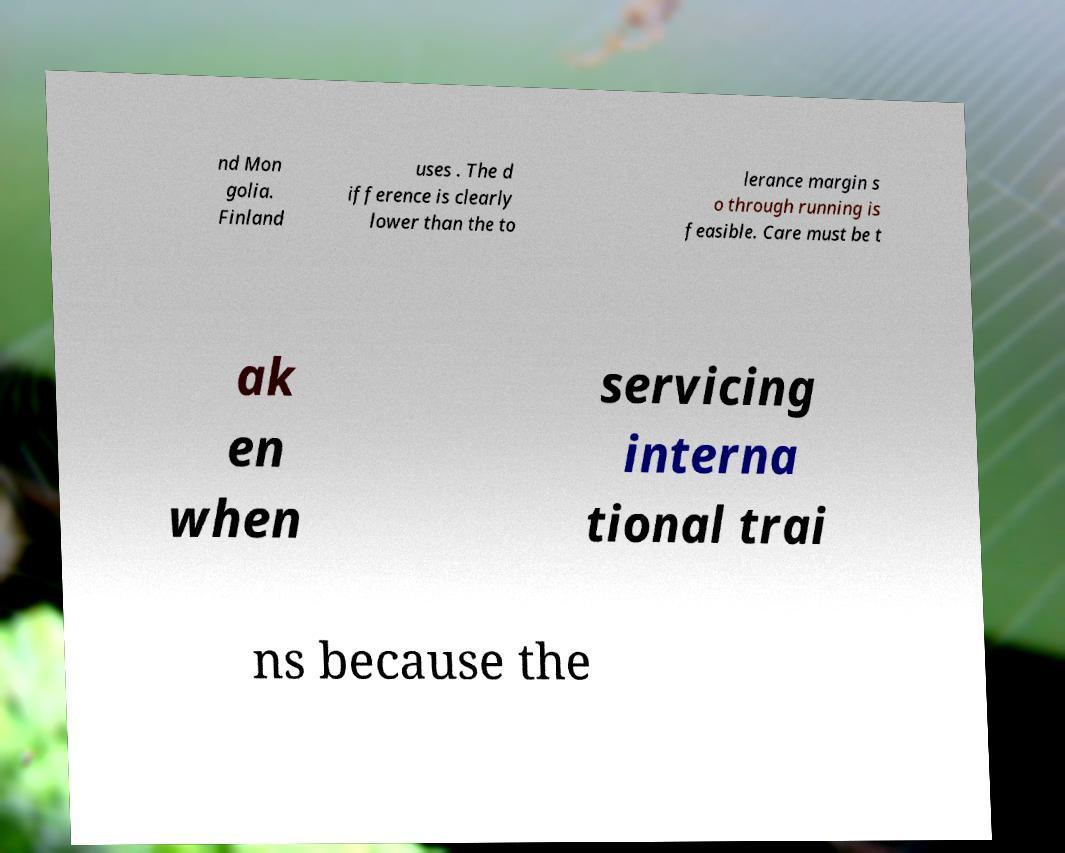For documentation purposes, I need the text within this image transcribed. Could you provide that? nd Mon golia. Finland uses . The d ifference is clearly lower than the to lerance margin s o through running is feasible. Care must be t ak en when servicing interna tional trai ns because the 